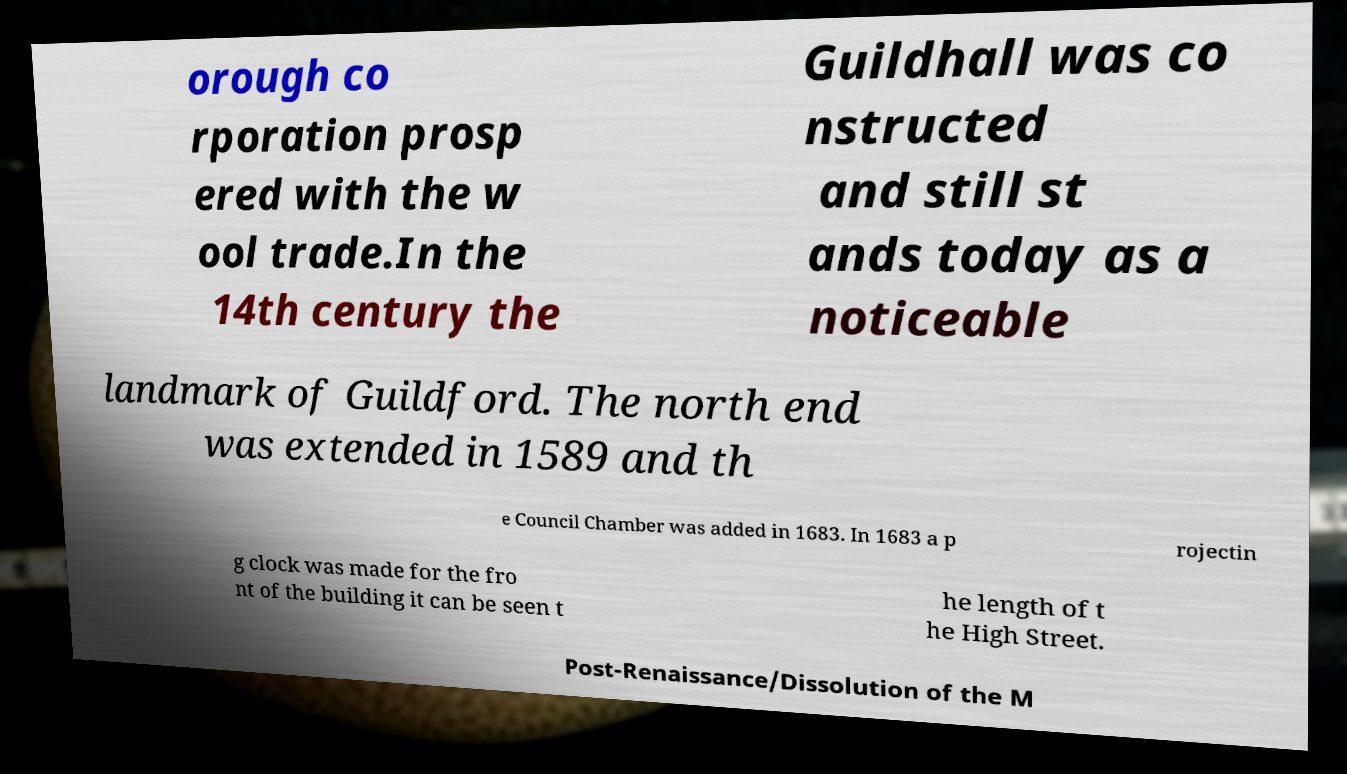Can you read and provide the text displayed in the image?This photo seems to have some interesting text. Can you extract and type it out for me? orough co rporation prosp ered with the w ool trade.In the 14th century the Guildhall was co nstructed and still st ands today as a noticeable landmark of Guildford. The north end was extended in 1589 and th e Council Chamber was added in 1683. In 1683 a p rojectin g clock was made for the fro nt of the building it can be seen t he length of t he High Street. Post-Renaissance/Dissolution of the M 